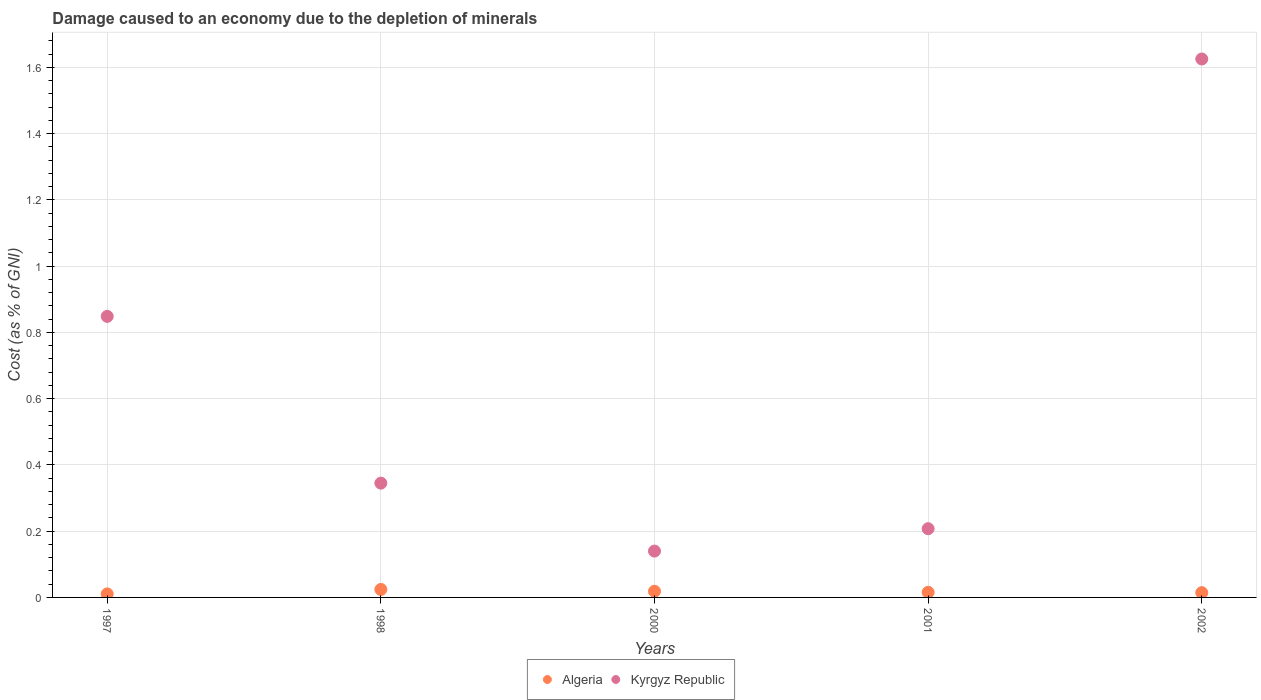How many different coloured dotlines are there?
Offer a very short reply. 2. Is the number of dotlines equal to the number of legend labels?
Give a very brief answer. Yes. What is the cost of damage caused due to the depletion of minerals in Kyrgyz Republic in 1997?
Provide a succinct answer. 0.85. Across all years, what is the maximum cost of damage caused due to the depletion of minerals in Kyrgyz Republic?
Offer a very short reply. 1.63. Across all years, what is the minimum cost of damage caused due to the depletion of minerals in Algeria?
Keep it short and to the point. 0.01. What is the total cost of damage caused due to the depletion of minerals in Kyrgyz Republic in the graph?
Give a very brief answer. 3.17. What is the difference between the cost of damage caused due to the depletion of minerals in Kyrgyz Republic in 2001 and that in 2002?
Give a very brief answer. -1.42. What is the difference between the cost of damage caused due to the depletion of minerals in Kyrgyz Republic in 2002 and the cost of damage caused due to the depletion of minerals in Algeria in 1997?
Provide a short and direct response. 1.61. What is the average cost of damage caused due to the depletion of minerals in Algeria per year?
Provide a succinct answer. 0.02. In the year 1998, what is the difference between the cost of damage caused due to the depletion of minerals in Kyrgyz Republic and cost of damage caused due to the depletion of minerals in Algeria?
Your response must be concise. 0.32. What is the ratio of the cost of damage caused due to the depletion of minerals in Algeria in 1998 to that in 2000?
Offer a very short reply. 1.29. What is the difference between the highest and the second highest cost of damage caused due to the depletion of minerals in Kyrgyz Republic?
Offer a terse response. 0.78. What is the difference between the highest and the lowest cost of damage caused due to the depletion of minerals in Kyrgyz Republic?
Your answer should be very brief. 1.49. In how many years, is the cost of damage caused due to the depletion of minerals in Kyrgyz Republic greater than the average cost of damage caused due to the depletion of minerals in Kyrgyz Republic taken over all years?
Provide a succinct answer. 2. Does the cost of damage caused due to the depletion of minerals in Kyrgyz Republic monotonically increase over the years?
Your answer should be very brief. No. Is the cost of damage caused due to the depletion of minerals in Kyrgyz Republic strictly greater than the cost of damage caused due to the depletion of minerals in Algeria over the years?
Make the answer very short. Yes. Is the cost of damage caused due to the depletion of minerals in Kyrgyz Republic strictly less than the cost of damage caused due to the depletion of minerals in Algeria over the years?
Ensure brevity in your answer.  No. How many years are there in the graph?
Keep it short and to the point. 5. What is the difference between two consecutive major ticks on the Y-axis?
Your answer should be very brief. 0.2. Does the graph contain any zero values?
Offer a terse response. No. Does the graph contain grids?
Provide a short and direct response. Yes. How many legend labels are there?
Offer a very short reply. 2. What is the title of the graph?
Your answer should be very brief. Damage caused to an economy due to the depletion of minerals. Does "Cote d'Ivoire" appear as one of the legend labels in the graph?
Make the answer very short. No. What is the label or title of the X-axis?
Provide a short and direct response. Years. What is the label or title of the Y-axis?
Ensure brevity in your answer.  Cost (as % of GNI). What is the Cost (as % of GNI) in Algeria in 1997?
Give a very brief answer. 0.01. What is the Cost (as % of GNI) of Kyrgyz Republic in 1997?
Offer a terse response. 0.85. What is the Cost (as % of GNI) of Algeria in 1998?
Offer a terse response. 0.02. What is the Cost (as % of GNI) in Kyrgyz Republic in 1998?
Offer a terse response. 0.35. What is the Cost (as % of GNI) of Algeria in 2000?
Offer a very short reply. 0.02. What is the Cost (as % of GNI) of Kyrgyz Republic in 2000?
Ensure brevity in your answer.  0.14. What is the Cost (as % of GNI) of Algeria in 2001?
Your response must be concise. 0.02. What is the Cost (as % of GNI) of Kyrgyz Republic in 2001?
Make the answer very short. 0.21. What is the Cost (as % of GNI) in Algeria in 2002?
Offer a very short reply. 0.01. What is the Cost (as % of GNI) of Kyrgyz Republic in 2002?
Keep it short and to the point. 1.63. Across all years, what is the maximum Cost (as % of GNI) of Algeria?
Keep it short and to the point. 0.02. Across all years, what is the maximum Cost (as % of GNI) in Kyrgyz Republic?
Ensure brevity in your answer.  1.63. Across all years, what is the minimum Cost (as % of GNI) of Algeria?
Your answer should be very brief. 0.01. Across all years, what is the minimum Cost (as % of GNI) of Kyrgyz Republic?
Offer a terse response. 0.14. What is the total Cost (as % of GNI) of Algeria in the graph?
Offer a terse response. 0.08. What is the total Cost (as % of GNI) of Kyrgyz Republic in the graph?
Your response must be concise. 3.17. What is the difference between the Cost (as % of GNI) of Algeria in 1997 and that in 1998?
Offer a terse response. -0.01. What is the difference between the Cost (as % of GNI) of Kyrgyz Republic in 1997 and that in 1998?
Offer a very short reply. 0.5. What is the difference between the Cost (as % of GNI) in Algeria in 1997 and that in 2000?
Offer a very short reply. -0.01. What is the difference between the Cost (as % of GNI) in Kyrgyz Republic in 1997 and that in 2000?
Provide a succinct answer. 0.71. What is the difference between the Cost (as % of GNI) of Algeria in 1997 and that in 2001?
Offer a very short reply. -0. What is the difference between the Cost (as % of GNI) of Kyrgyz Republic in 1997 and that in 2001?
Keep it short and to the point. 0.64. What is the difference between the Cost (as % of GNI) of Algeria in 1997 and that in 2002?
Make the answer very short. -0. What is the difference between the Cost (as % of GNI) of Kyrgyz Republic in 1997 and that in 2002?
Your answer should be compact. -0.78. What is the difference between the Cost (as % of GNI) of Algeria in 1998 and that in 2000?
Keep it short and to the point. 0.01. What is the difference between the Cost (as % of GNI) in Kyrgyz Republic in 1998 and that in 2000?
Ensure brevity in your answer.  0.21. What is the difference between the Cost (as % of GNI) in Algeria in 1998 and that in 2001?
Provide a succinct answer. 0.01. What is the difference between the Cost (as % of GNI) in Kyrgyz Republic in 1998 and that in 2001?
Make the answer very short. 0.14. What is the difference between the Cost (as % of GNI) in Algeria in 1998 and that in 2002?
Your answer should be compact. 0.01. What is the difference between the Cost (as % of GNI) of Kyrgyz Republic in 1998 and that in 2002?
Keep it short and to the point. -1.28. What is the difference between the Cost (as % of GNI) in Algeria in 2000 and that in 2001?
Offer a very short reply. 0. What is the difference between the Cost (as % of GNI) in Kyrgyz Republic in 2000 and that in 2001?
Give a very brief answer. -0.07. What is the difference between the Cost (as % of GNI) in Algeria in 2000 and that in 2002?
Provide a succinct answer. 0. What is the difference between the Cost (as % of GNI) of Kyrgyz Republic in 2000 and that in 2002?
Offer a very short reply. -1.49. What is the difference between the Cost (as % of GNI) in Kyrgyz Republic in 2001 and that in 2002?
Give a very brief answer. -1.42. What is the difference between the Cost (as % of GNI) of Algeria in 1997 and the Cost (as % of GNI) of Kyrgyz Republic in 1998?
Ensure brevity in your answer.  -0.33. What is the difference between the Cost (as % of GNI) of Algeria in 1997 and the Cost (as % of GNI) of Kyrgyz Republic in 2000?
Your answer should be compact. -0.13. What is the difference between the Cost (as % of GNI) in Algeria in 1997 and the Cost (as % of GNI) in Kyrgyz Republic in 2001?
Offer a very short reply. -0.2. What is the difference between the Cost (as % of GNI) in Algeria in 1997 and the Cost (as % of GNI) in Kyrgyz Republic in 2002?
Provide a short and direct response. -1.61. What is the difference between the Cost (as % of GNI) of Algeria in 1998 and the Cost (as % of GNI) of Kyrgyz Republic in 2000?
Offer a very short reply. -0.12. What is the difference between the Cost (as % of GNI) in Algeria in 1998 and the Cost (as % of GNI) in Kyrgyz Republic in 2001?
Your response must be concise. -0.18. What is the difference between the Cost (as % of GNI) in Algeria in 1998 and the Cost (as % of GNI) in Kyrgyz Republic in 2002?
Provide a succinct answer. -1.6. What is the difference between the Cost (as % of GNI) of Algeria in 2000 and the Cost (as % of GNI) of Kyrgyz Republic in 2001?
Offer a terse response. -0.19. What is the difference between the Cost (as % of GNI) of Algeria in 2000 and the Cost (as % of GNI) of Kyrgyz Republic in 2002?
Your answer should be very brief. -1.61. What is the difference between the Cost (as % of GNI) in Algeria in 2001 and the Cost (as % of GNI) in Kyrgyz Republic in 2002?
Make the answer very short. -1.61. What is the average Cost (as % of GNI) of Algeria per year?
Give a very brief answer. 0.02. What is the average Cost (as % of GNI) of Kyrgyz Republic per year?
Offer a terse response. 0.63. In the year 1997, what is the difference between the Cost (as % of GNI) in Algeria and Cost (as % of GNI) in Kyrgyz Republic?
Your answer should be compact. -0.84. In the year 1998, what is the difference between the Cost (as % of GNI) of Algeria and Cost (as % of GNI) of Kyrgyz Republic?
Offer a terse response. -0.32. In the year 2000, what is the difference between the Cost (as % of GNI) of Algeria and Cost (as % of GNI) of Kyrgyz Republic?
Your answer should be compact. -0.12. In the year 2001, what is the difference between the Cost (as % of GNI) of Algeria and Cost (as % of GNI) of Kyrgyz Republic?
Give a very brief answer. -0.19. In the year 2002, what is the difference between the Cost (as % of GNI) in Algeria and Cost (as % of GNI) in Kyrgyz Republic?
Your answer should be very brief. -1.61. What is the ratio of the Cost (as % of GNI) of Algeria in 1997 to that in 1998?
Provide a short and direct response. 0.44. What is the ratio of the Cost (as % of GNI) of Kyrgyz Republic in 1997 to that in 1998?
Provide a short and direct response. 2.46. What is the ratio of the Cost (as % of GNI) of Algeria in 1997 to that in 2000?
Ensure brevity in your answer.  0.57. What is the ratio of the Cost (as % of GNI) of Kyrgyz Republic in 1997 to that in 2000?
Provide a succinct answer. 6.07. What is the ratio of the Cost (as % of GNI) in Algeria in 1997 to that in 2001?
Ensure brevity in your answer.  0.69. What is the ratio of the Cost (as % of GNI) of Kyrgyz Republic in 1997 to that in 2001?
Make the answer very short. 4.09. What is the ratio of the Cost (as % of GNI) in Algeria in 1997 to that in 2002?
Your response must be concise. 0.74. What is the ratio of the Cost (as % of GNI) in Kyrgyz Republic in 1997 to that in 2002?
Your answer should be very brief. 0.52. What is the ratio of the Cost (as % of GNI) in Algeria in 1998 to that in 2000?
Provide a succinct answer. 1.29. What is the ratio of the Cost (as % of GNI) in Kyrgyz Republic in 1998 to that in 2000?
Give a very brief answer. 2.47. What is the ratio of the Cost (as % of GNI) in Algeria in 1998 to that in 2001?
Your response must be concise. 1.56. What is the ratio of the Cost (as % of GNI) in Kyrgyz Republic in 1998 to that in 2001?
Give a very brief answer. 1.66. What is the ratio of the Cost (as % of GNI) of Algeria in 1998 to that in 2002?
Provide a succinct answer. 1.67. What is the ratio of the Cost (as % of GNI) of Kyrgyz Republic in 1998 to that in 2002?
Make the answer very short. 0.21. What is the ratio of the Cost (as % of GNI) in Algeria in 2000 to that in 2001?
Provide a succinct answer. 1.21. What is the ratio of the Cost (as % of GNI) in Kyrgyz Republic in 2000 to that in 2001?
Provide a short and direct response. 0.67. What is the ratio of the Cost (as % of GNI) of Algeria in 2000 to that in 2002?
Offer a very short reply. 1.29. What is the ratio of the Cost (as % of GNI) of Kyrgyz Republic in 2000 to that in 2002?
Offer a very short reply. 0.09. What is the ratio of the Cost (as % of GNI) of Algeria in 2001 to that in 2002?
Ensure brevity in your answer.  1.07. What is the ratio of the Cost (as % of GNI) of Kyrgyz Republic in 2001 to that in 2002?
Your response must be concise. 0.13. What is the difference between the highest and the second highest Cost (as % of GNI) in Algeria?
Give a very brief answer. 0.01. What is the difference between the highest and the second highest Cost (as % of GNI) of Kyrgyz Republic?
Provide a short and direct response. 0.78. What is the difference between the highest and the lowest Cost (as % of GNI) in Algeria?
Provide a succinct answer. 0.01. What is the difference between the highest and the lowest Cost (as % of GNI) of Kyrgyz Republic?
Provide a short and direct response. 1.49. 